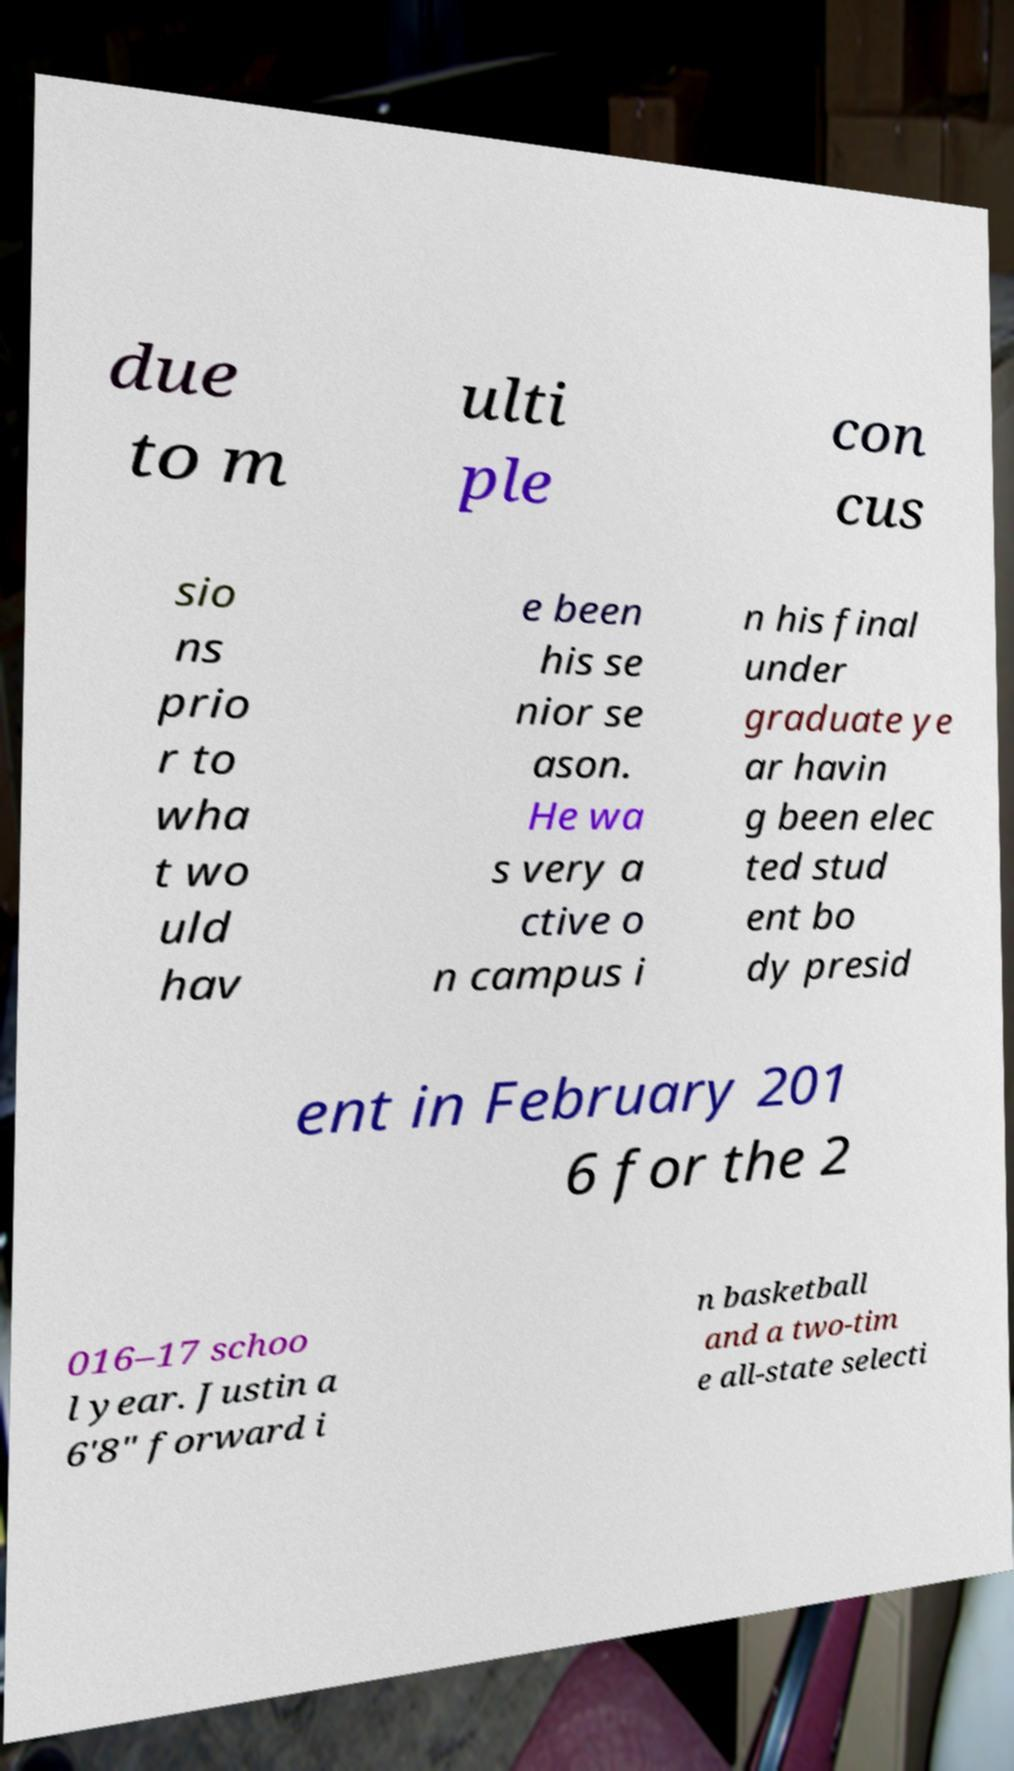What messages or text are displayed in this image? I need them in a readable, typed format. due to m ulti ple con cus sio ns prio r to wha t wo uld hav e been his se nior se ason. He wa s very a ctive o n campus i n his final under graduate ye ar havin g been elec ted stud ent bo dy presid ent in February 201 6 for the 2 016–17 schoo l year. Justin a 6'8" forward i n basketball and a two-tim e all-state selecti 